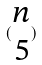Convert formula to latex. <formula><loc_0><loc_0><loc_500><loc_500>( \begin{matrix} n \\ 5 \end{matrix} )</formula> 